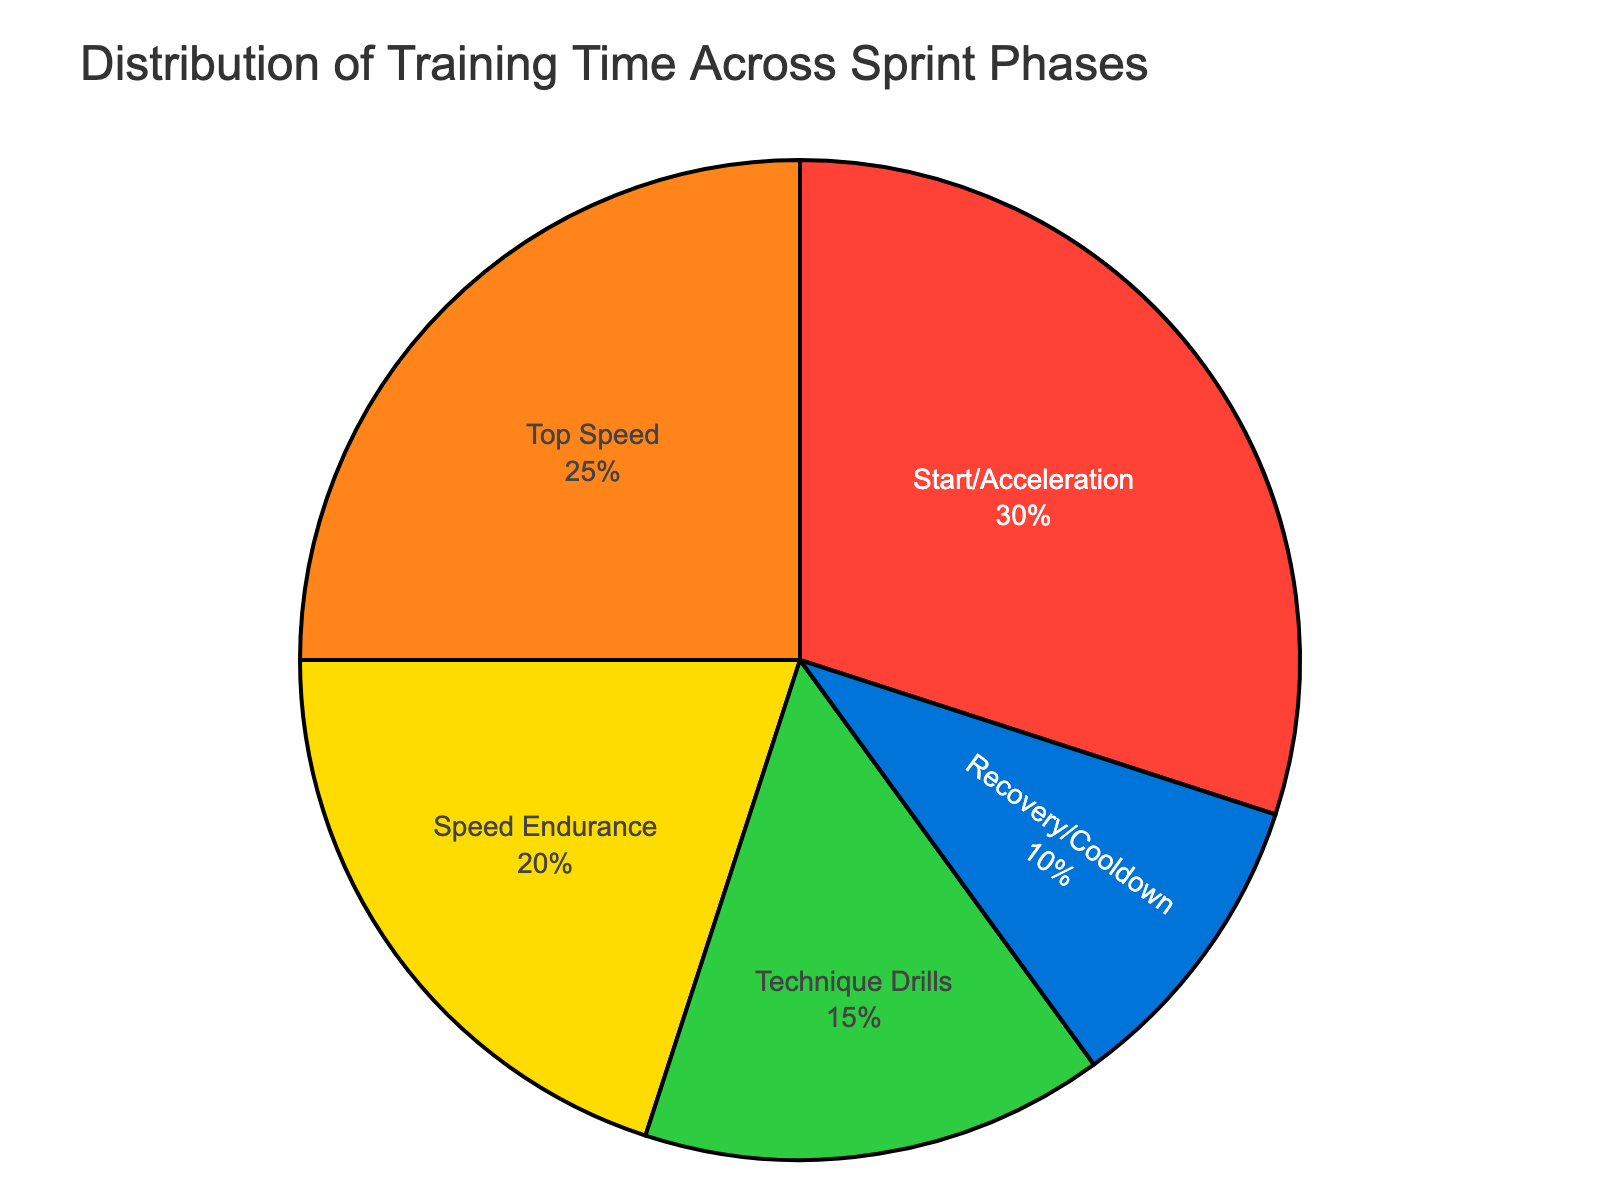Which phase occupies the largest portion of training time? The slice with the largest percentage in the pie chart represents the 'Start/Acceleration' phase, which occupies 30%.
Answer: Start/Acceleration How much more time is spent on the 'Top Speed' phase compared to the 'Recovery/Cooldown' phase? The 'Top Speed' phase accounts for 25% of training time, while the 'Recovery/Cooldown' phase accounts for 10%. The difference is 25% - 10% = 15%.
Answer: 15% Which phases together cover exactly half of the training time? The 'Start/Acceleration' (30%) and 'Speed Endurance' (20%) together make 30% + 20% = 50%.
Answer: Start/Acceleration and Speed Endurance How much time is spent on phases other than 'Start/Acceleration'? The 'Start/Acceleration' phase accounts for 30%. The total percentage for all other phases is 100% - 30% = 70%.
Answer: 70% Which phase has the smallest proportion of training time? The smallest slice on the pie chart represents the 'Recovery/Cooldown' phase, which is 10%.
Answer: Recovery/Cooldown What is the combined percentage of the 'Speed Endurance' and 'Technique Drills' phases? The 'Speed Endurance' phase occupies 20%, and the 'Technique Drills' phase covers 15%. The combined percentage is 20% + 15% = 35%.
Answer: 35% How does the 'Top Speed' phase compare in size to the 'Technique Drills' phase? The 'Top Speed' phase is 25%, which is 10% larger than the 'Technique Drills' phase, which is 15%.
Answer: 10% larger What is the average percentage of time spent on all phases? The total sum of all percentages is 30% + 25% + 20% + 15% + 10% = 100%. There are 5 phases, so the average is 100% / 5 = 20%.
Answer: 20% 